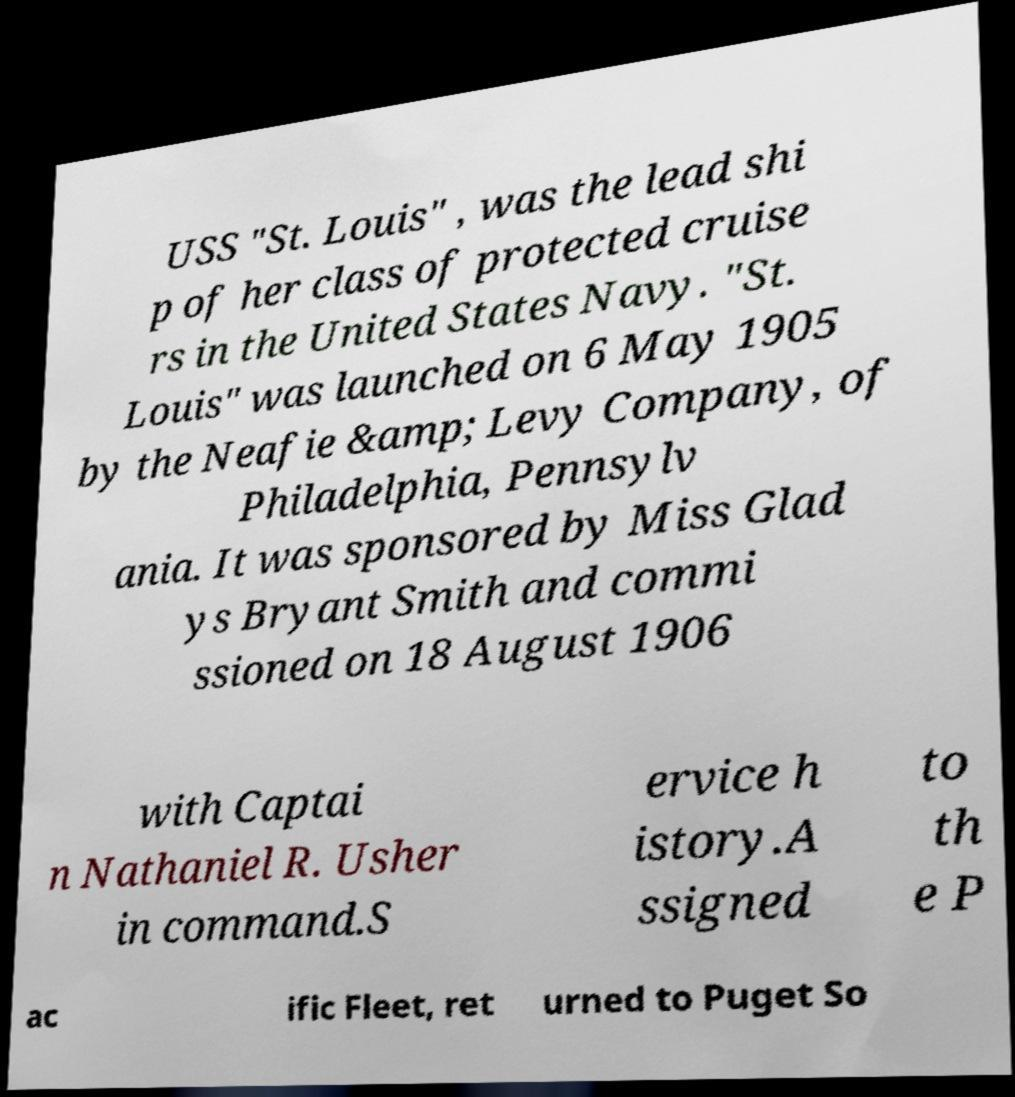Could you assist in decoding the text presented in this image and type it out clearly? USS "St. Louis" , was the lead shi p of her class of protected cruise rs in the United States Navy. "St. Louis" was launched on 6 May 1905 by the Neafie &amp; Levy Company, of Philadelphia, Pennsylv ania. It was sponsored by Miss Glad ys Bryant Smith and commi ssioned on 18 August 1906 with Captai n Nathaniel R. Usher in command.S ervice h istory.A ssigned to th e P ac ific Fleet, ret urned to Puget So 